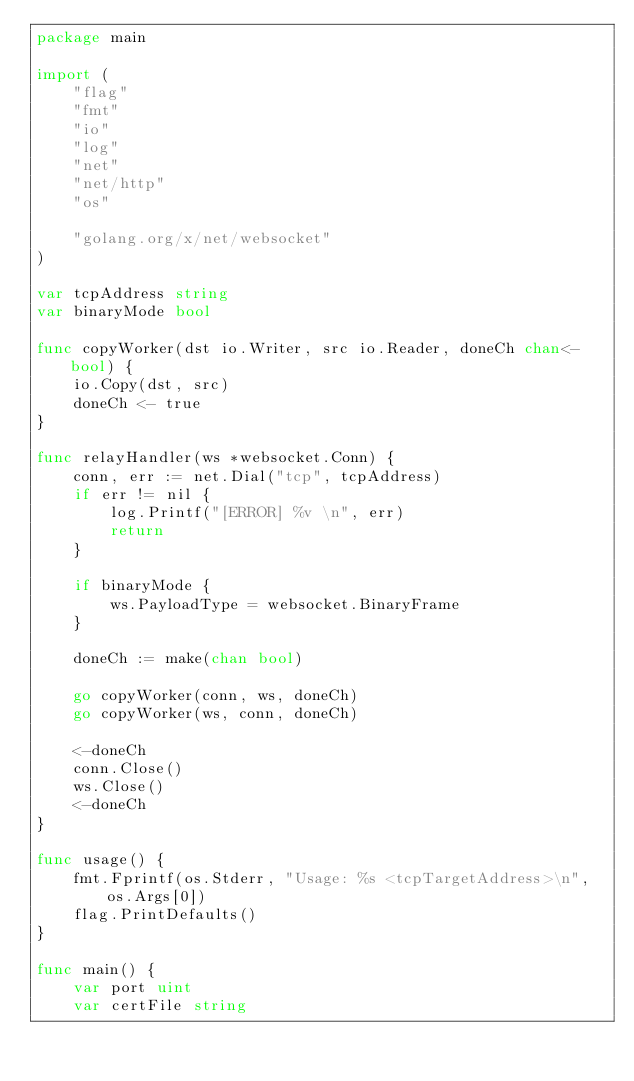<code> <loc_0><loc_0><loc_500><loc_500><_Go_>package main

import (
	"flag"
	"fmt"
	"io"
	"log"
	"net"
	"net/http"
	"os"

	"golang.org/x/net/websocket"
)

var tcpAddress string
var binaryMode bool

func copyWorker(dst io.Writer, src io.Reader, doneCh chan<- bool) {
	io.Copy(dst, src)
	doneCh <- true
}

func relayHandler(ws *websocket.Conn) {
	conn, err := net.Dial("tcp", tcpAddress)
	if err != nil {
		log.Printf("[ERROR] %v \n", err)
		return
	}

	if binaryMode {
		ws.PayloadType = websocket.BinaryFrame
	}

	doneCh := make(chan bool)

	go copyWorker(conn, ws, doneCh)
	go copyWorker(ws, conn, doneCh)

	<-doneCh
	conn.Close()
	ws.Close()
	<-doneCh
}

func usage() {
	fmt.Fprintf(os.Stderr, "Usage: %s <tcpTargetAddress>\n", os.Args[0])
	flag.PrintDefaults()
}

func main() {
	var port uint
	var certFile string</code> 